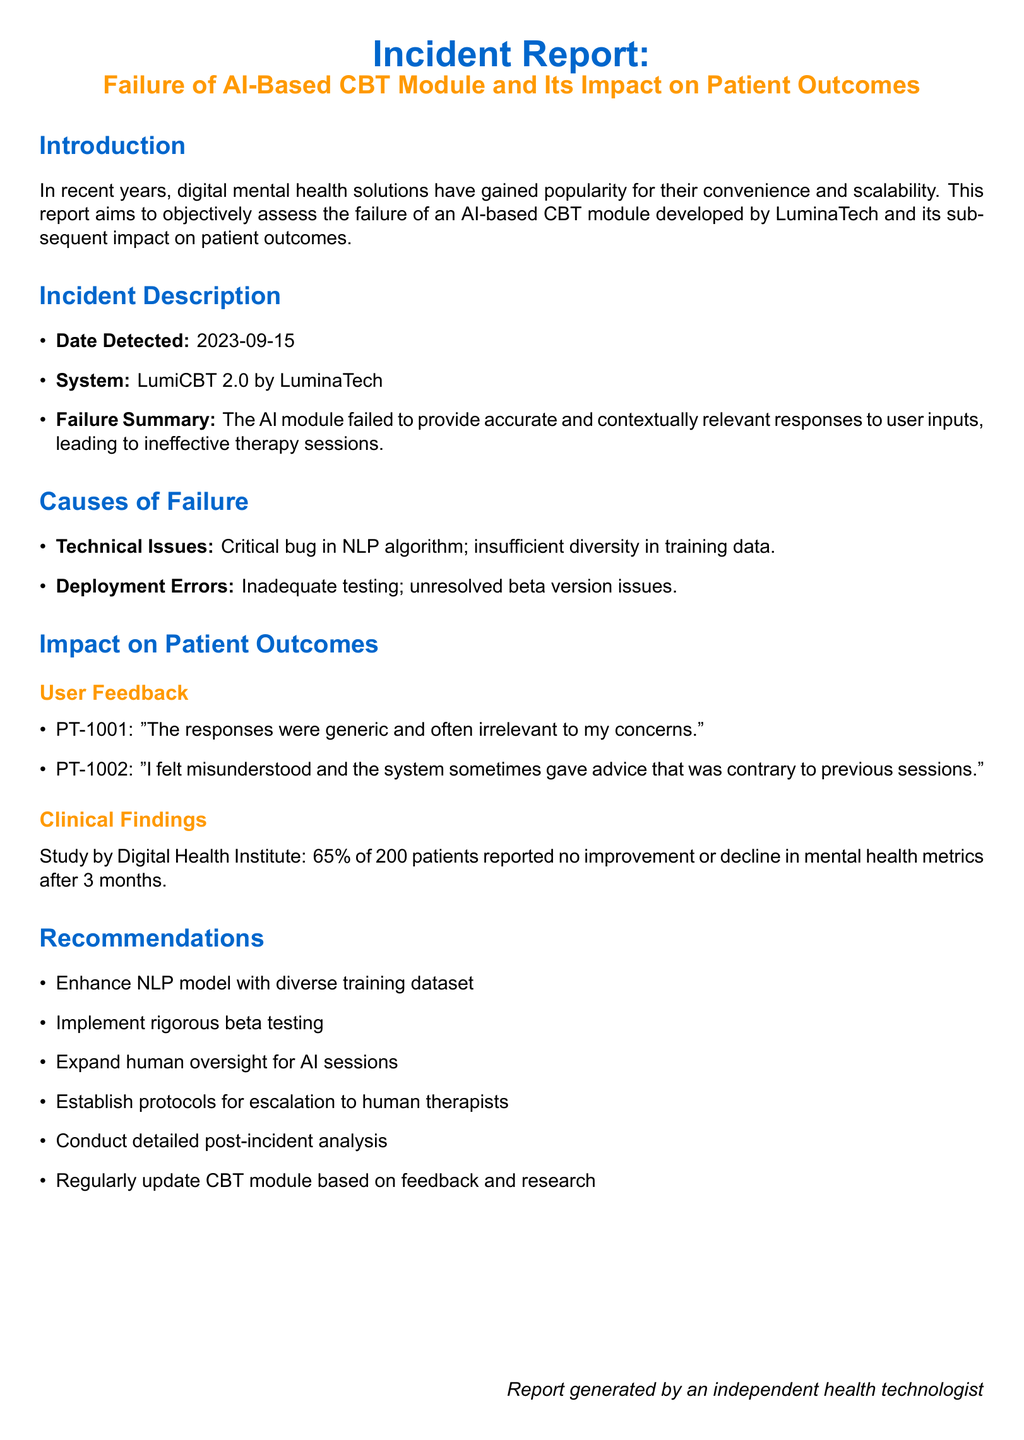what is the date the issue was detected? The date the issue was detected is mentioned in the document under the incident description section.
Answer: 2023-09-15 who developed the AI-based CBT module? The document specifies the developer of the AI-based CBT module in the incident description section.
Answer: LuminaTech what percentage of patients reported no improvement in mental health metrics? The document provides a statistic related to patient feedback in the clinical findings section.
Answer: 65% what were the two main technical issues identified? The causes of failure section outlines the primary technical issues that led to the incident.
Answer: Critical bug in NLP algorithm; insufficient diversity in training data what is one recommendation for enhancing the AI module? The recommendations section includes suggestions for improvement to the AI module.
Answer: Enhance NLP model with diverse training dataset how many patients were included in the study by the Digital Health Institute? The clinical findings section mentions the number of patients involved in the study conducted.
Answer: 200 what was a common user feedback regarding the AI module? User feedback is presented in a subsection that highlights patient experiences with the AI module.
Answer: "The responses were generic and often irrelevant to my concerns." what type of report is this? The title section identifies the nature of the document.
Answer: Incident Report 